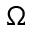Convert formula to latex. <formula><loc_0><loc_0><loc_500><loc_500>\Omega</formula> 